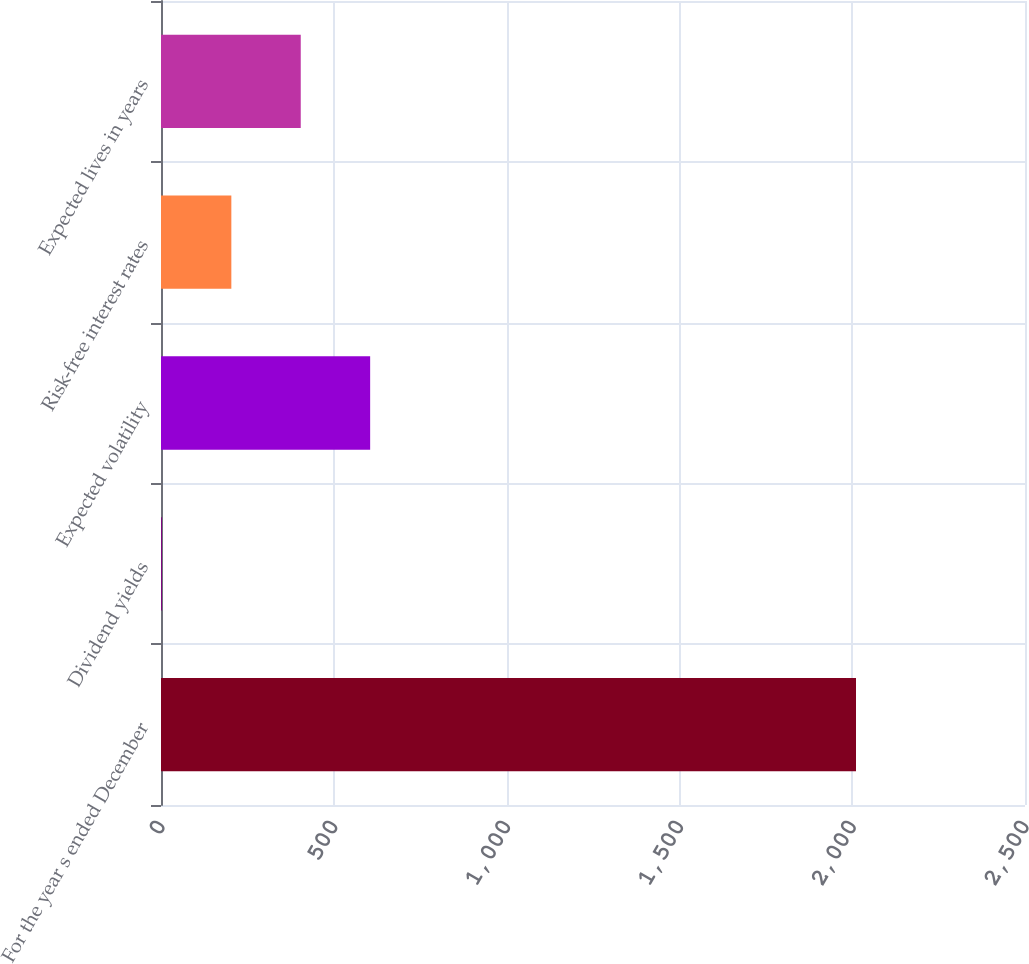<chart> <loc_0><loc_0><loc_500><loc_500><bar_chart><fcel>For the year s ended December<fcel>Dividend yields<fcel>Expected volatility<fcel>Risk-free interest rates<fcel>Expected lives in years<nl><fcel>2011<fcel>2.7<fcel>605.19<fcel>203.53<fcel>404.36<nl></chart> 